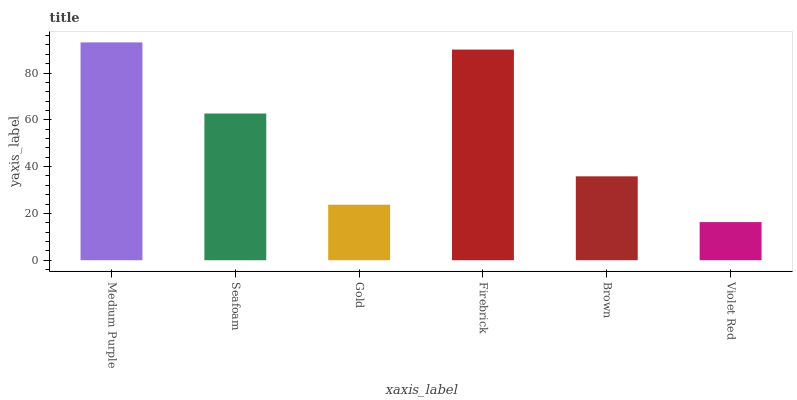Is Violet Red the minimum?
Answer yes or no. Yes. Is Medium Purple the maximum?
Answer yes or no. Yes. Is Seafoam the minimum?
Answer yes or no. No. Is Seafoam the maximum?
Answer yes or no. No. Is Medium Purple greater than Seafoam?
Answer yes or no. Yes. Is Seafoam less than Medium Purple?
Answer yes or no. Yes. Is Seafoam greater than Medium Purple?
Answer yes or no. No. Is Medium Purple less than Seafoam?
Answer yes or no. No. Is Seafoam the high median?
Answer yes or no. Yes. Is Brown the low median?
Answer yes or no. Yes. Is Medium Purple the high median?
Answer yes or no. No. Is Medium Purple the low median?
Answer yes or no. No. 